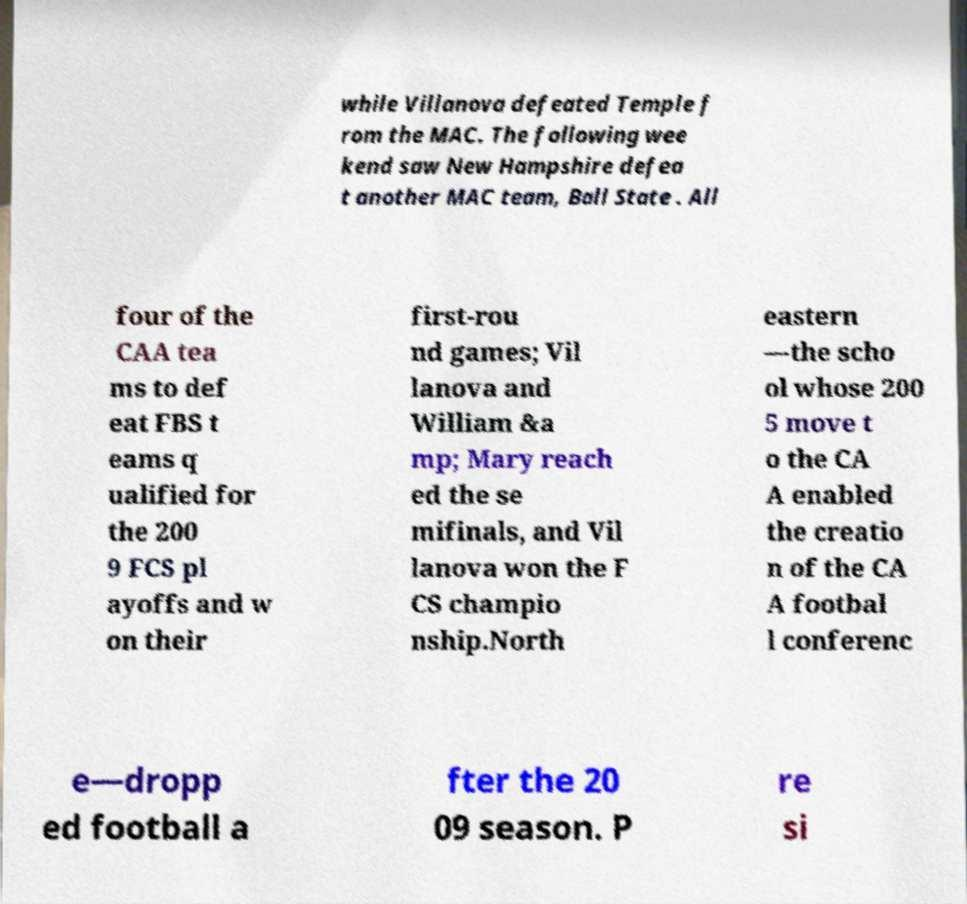Please identify and transcribe the text found in this image. while Villanova defeated Temple f rom the MAC. The following wee kend saw New Hampshire defea t another MAC team, Ball State . All four of the CAA tea ms to def eat FBS t eams q ualified for the 200 9 FCS pl ayoffs and w on their first-rou nd games; Vil lanova and William &a mp; Mary reach ed the se mifinals, and Vil lanova won the F CS champio nship.North eastern —the scho ol whose 200 5 move t o the CA A enabled the creatio n of the CA A footbal l conferenc e—dropp ed football a fter the 20 09 season. P re si 